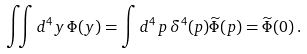Convert formula to latex. <formula><loc_0><loc_0><loc_500><loc_500>\iint d ^ { 4 } y \, \Phi ( y ) = \int d ^ { 4 } \, p \, \delta ^ { 4 } ( p ) \widetilde { \Phi } ( p ) = \widetilde { \Phi } ( 0 ) \, .</formula> 